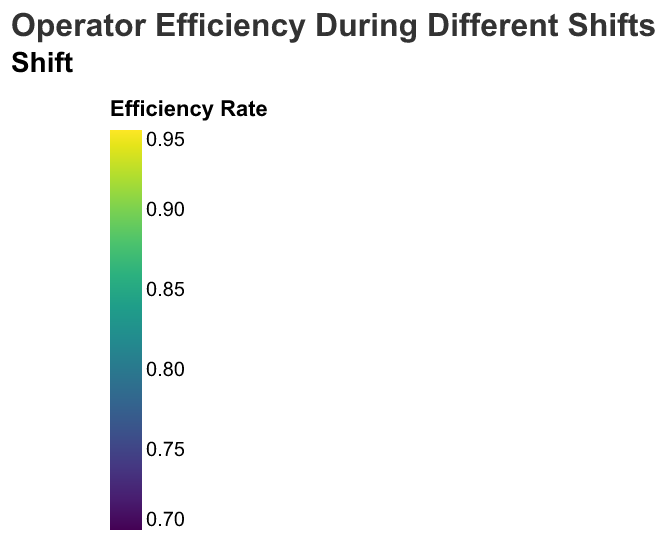What is the title of the figure? The title of the figure is usually placed at the top and serves as a description of what the figure represents. In this case, the title is "Operator Efficiency During Different Shifts".
Answer: Operator Efficiency During Different Shifts Which shift has the highest average efficiency rate for the "Customer Service" task? To find the shift with the highest average efficiency rate for "Customer Service", look at the color intensity of the rectangles corresponding to the Customer Service task in each shift. Higher efficiency rates correspond to more intense colors. The Morning shift shows the deepest color.
Answer: Morning Which operator shows the highest efficiency rate in "Quality Control"? To determine the operator with the highest efficiency rate for "Quality Control", examine the color intensities of the rectangles under the "Quality Control" task for all operators. The most intense color corresponds to Operator_01 in the Morning shift.
Answer: Operator_01 By how much does Operator_05's efficiency rate for "Order Processing" change from the Morning shift to the Evening shift? Find the efficiency rates for Operator_05 in "Order Processing" for both the Morning (0.79) and Evening (0.74) shifts. The change can be calculated as the difference: 0.79 - 0.74.
Answer: 0.05 Which task shows the least variation in efficiency rates across all operators during the Afternoon shift? To determine which task shows the least variation in efficiency rates across operators during the Afternoon shift, observe the color intensity for all tasks under the Afternoon shift. "Quality Control" displays a nearly uniform color for all operators, indicating minimal variation.
Answer: Quality Control How does Operator_02's efficiency rate for "Inventory Management" compare between the Afternoon and Evening shifts? Look at the color levels for Operator_02 in "Inventory Management" for both Afternoon and Evening shifts. In the Afternoon shift, the rate is 0.81, and in the Evening shift, it is 0.78. The Afternoon rate is higher.
Answer: Afternoon is higher What is the overall trend in efficiency rates from Morning to Evening shifts for all tasks combined? Observing the color changes from Morning to Evening shifts for all tasks and operators reveals a gradual decrease in intensity, indicating a general decline in efficiency rates.
Answer: Decline Which operator performs consistently well across all tasks and shifts? Review the color intensities across all tasks and shifts for each operator. Operator_01 displays consistent high-intensity colors, suggesting strong performance across the board.
Answer: Operator_01 In which shift is there the largest disparity between the highest and lowest efficiency rates for "Inventory Management"? Examine the range of color intensities for the "Inventory Management" task across shifts. The Evening shift shows a significant disparity, with Operator_01 having a higher rate (dark color) and lower rates (lighter colors) for other operators.
Answer: Evening 